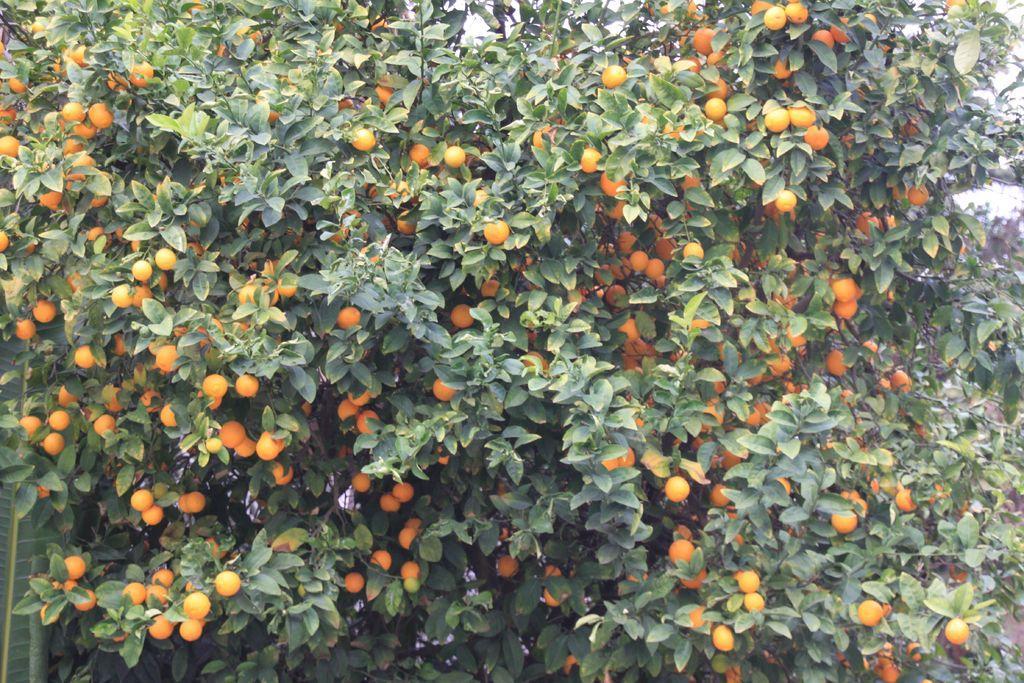How would you summarize this image in a sentence or two? This is the picture of a tree to which there are some oranges. 